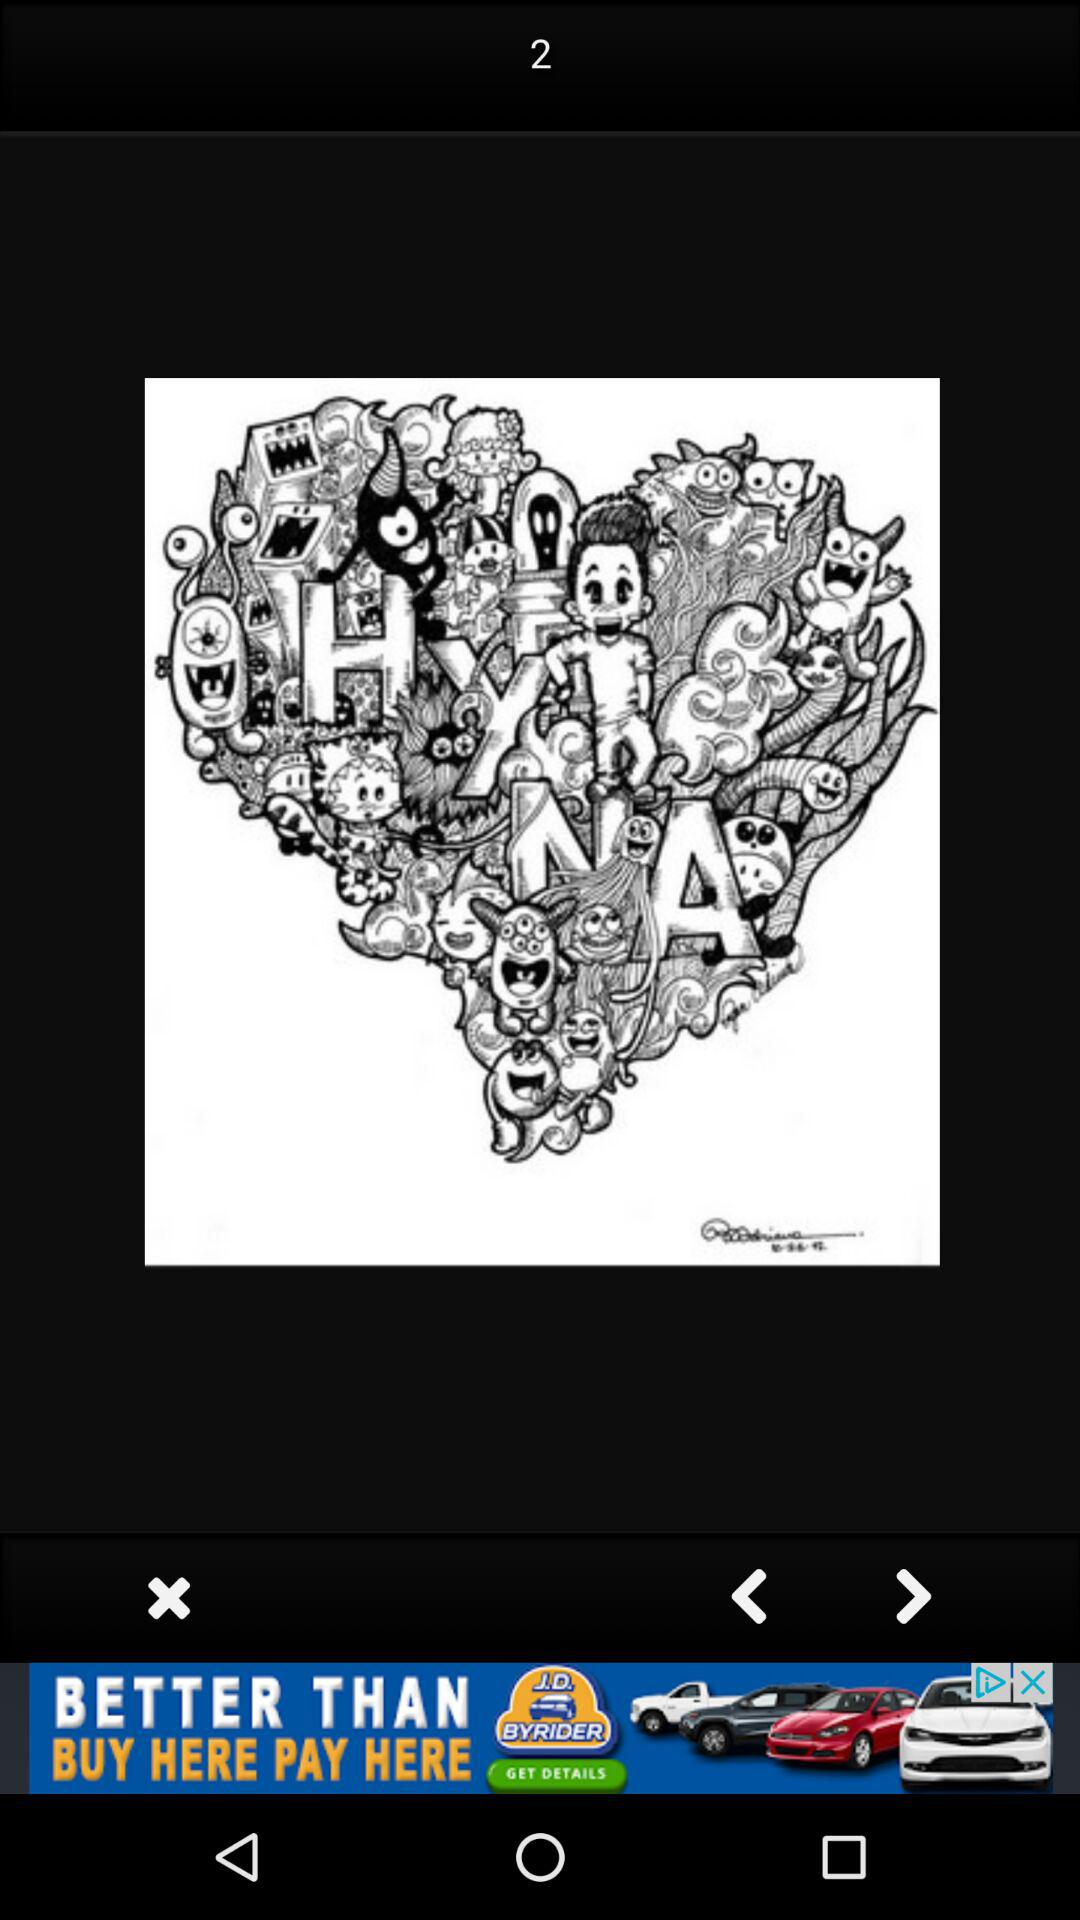Which image number is shown? The shown image number is 2. 